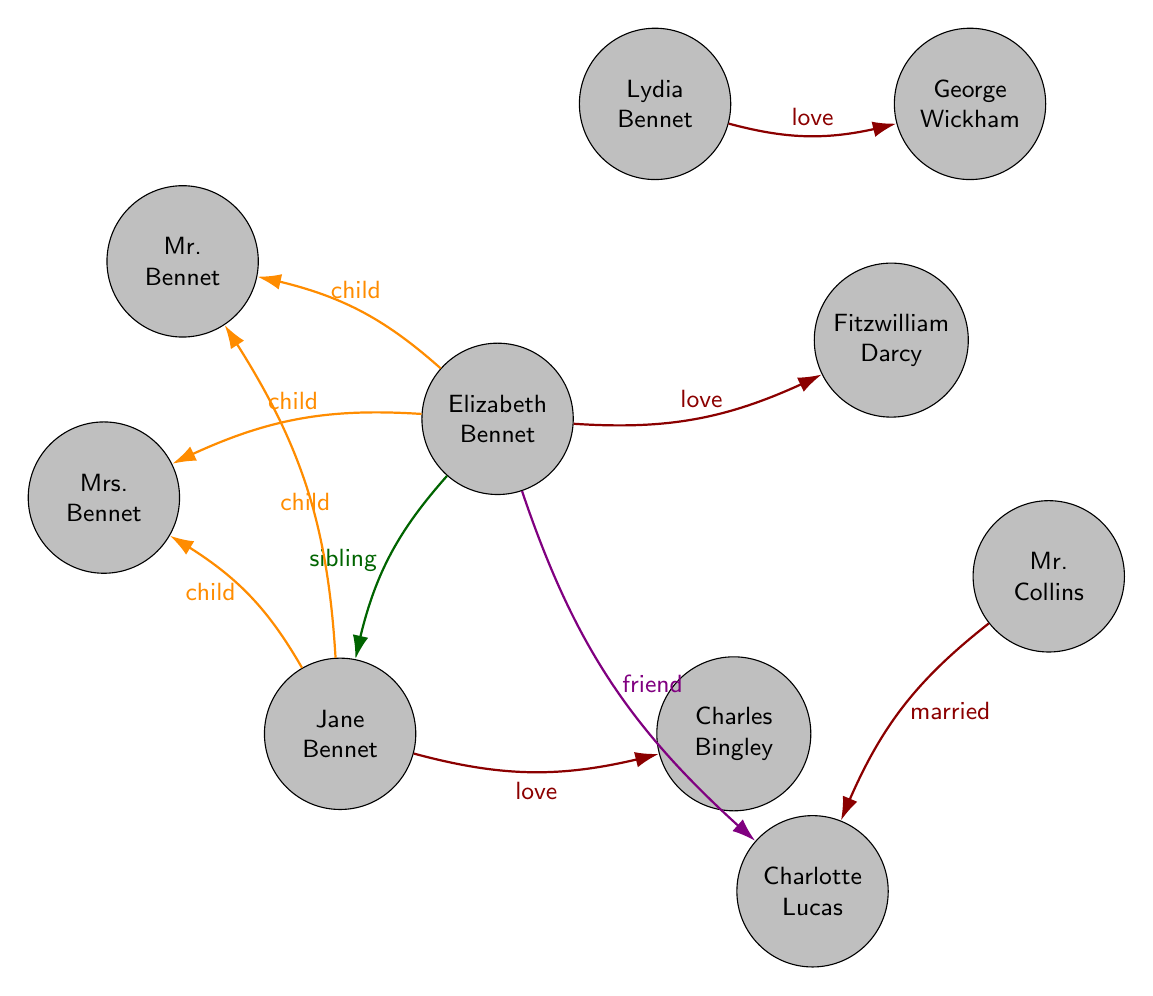What is the relationship between Elizabeth Bennet and Fitzwilliam Darcy? The diagram shows a direct link labeled "love," indicating that Elizabeth Bennet's relationship with Fitzwilliam Darcy is that of a love interest.
Answer: love interest Who is the parent of Jane Bennet? The links in the diagram show connections from Jane Bennet to both Mr. Bennet and Mrs. Bennet, indicating that they are her parents.
Answer: Mr. Bennet, Mrs. Bennet How many characters are in the diagram? The diagram has ten distinct nodes representing different characters, hence the total count is ten.
Answer: 10 Which character is a friend of Elizabeth Bennet? According to the diagram, there is a link labeled "friend" connecting Elizabeth Bennet to Charlotte Lucas, indicating their friendship.
Answer: Charlotte Lucas What type of relationship exists between Lydia Bennet and George Wickham? The diagram reflects a direct link labeled "love," indicating that Lydia Bennet and George Wickham have a romantic relationship as love interests.
Answer: love interest How many love interests are represented in the diagram? By examining the links classified as "love," there are three pairs showcasing love interests: Elizabeth and Darcy, Jane and Bingley, and Lydia and Wickham, leading to a total of three love interest links.
Answer: 3 Who is married to Charlotte Lucas? The diagram illustrates a direct link labeled "married" from Mr. Collins to Charlotte Lucas, indicating Mr. Collins is the one married to her.
Answer: Mr. Collins What is the sibling relationship in the diagram? The diagram indicates that Elizabeth Bennet and Jane Bennet are connected with a link labeled "sibling," showing that they are sisters.
Answer: Elizabeth Bennet, Jane Bennet 